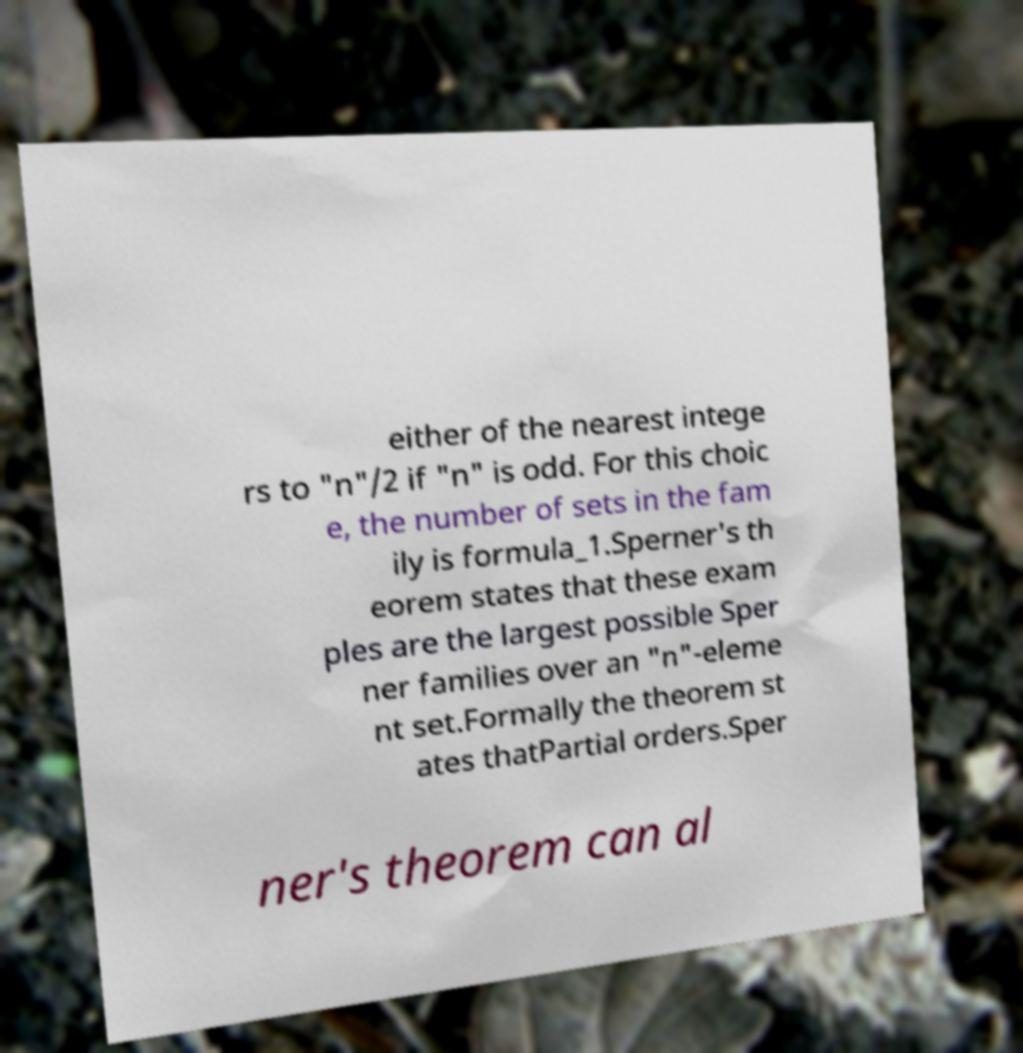Please read and relay the text visible in this image. What does it say? either of the nearest intege rs to "n"/2 if "n" is odd. For this choic e, the number of sets in the fam ily is formula_1.Sperner's th eorem states that these exam ples are the largest possible Sper ner families over an "n"-eleme nt set.Formally the theorem st ates thatPartial orders.Sper ner's theorem can al 